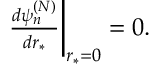Convert formula to latex. <formula><loc_0><loc_0><loc_500><loc_500>\begin{array} { r } { \frac { d \psi _ { n } ^ { ( N ) } } { d r _ { * } } \Big | _ { r _ { * } = 0 } = 0 . } \end{array}</formula> 